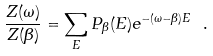<formula> <loc_0><loc_0><loc_500><loc_500>\frac { Z ( \omega ) } { Z ( \beta ) } = \sum _ { E } P _ { \beta } ( E ) e ^ { - ( \omega - \beta ) E } \ .</formula> 